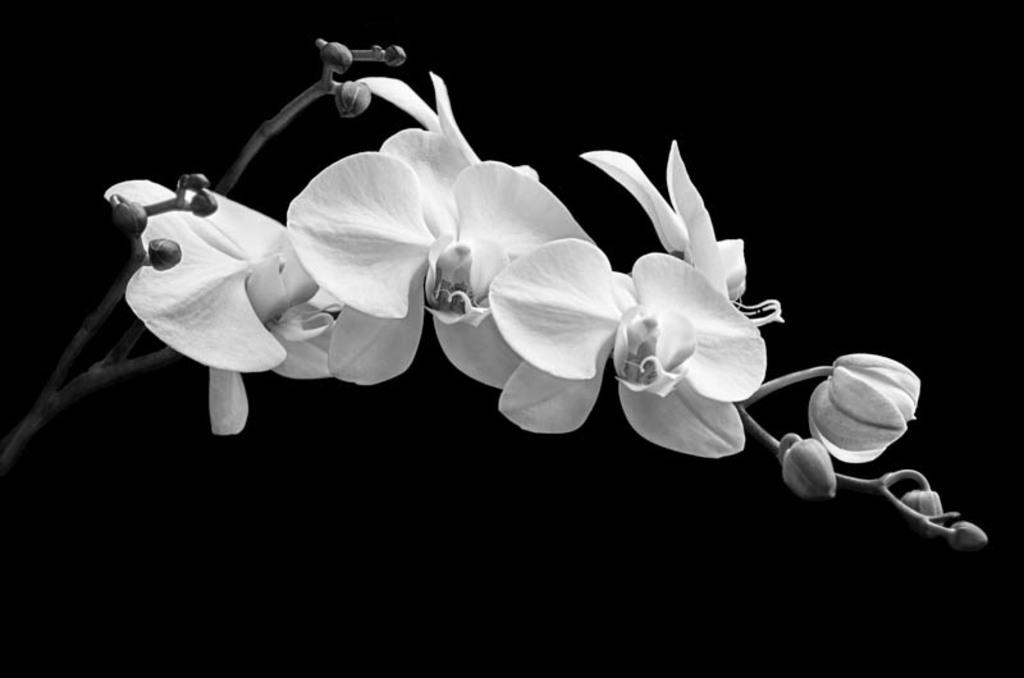What type of living organisms are present in the image? There are flowers in the image. How are the flowers connected to their stems? The flowers are attached to stems. What is the color scheme of the image? The image is black and white. What can be observed about the background of the image? The background of the image is dark. What type of scarf can be seen draped over the flowers in the image? There is no scarf present in the image; it features only flowers and their stems. Can you tell me how much milk is being poured over the flowers in the image? There is no milk present in the image; it features only flowers and their stems. 